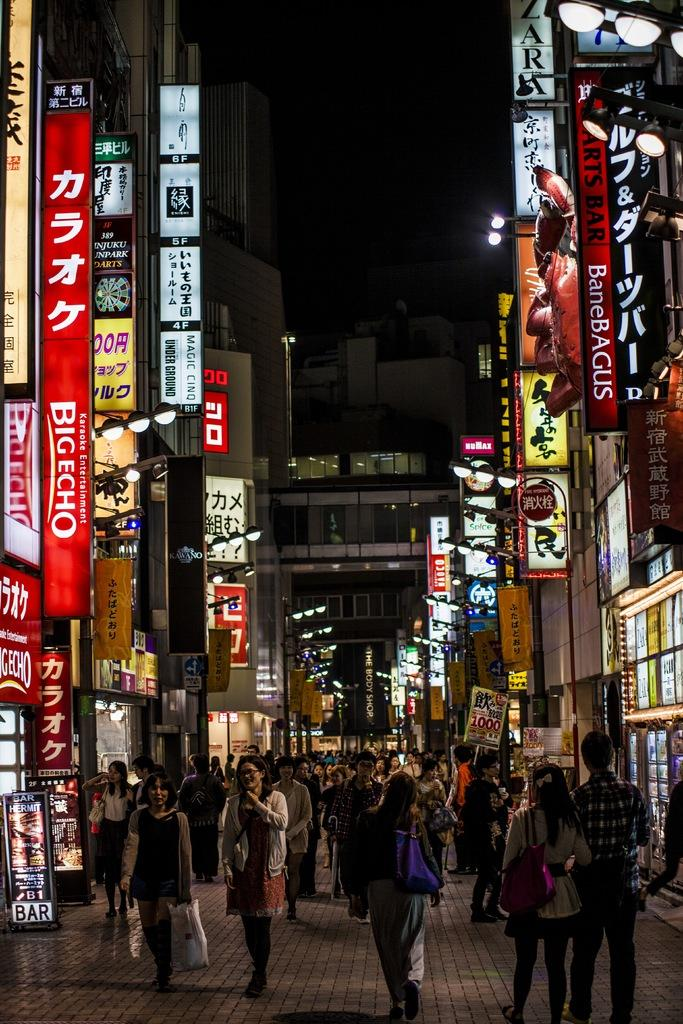Provide a one-sentence caption for the provided image. A street full of people and signs one of which says Big Echo. 